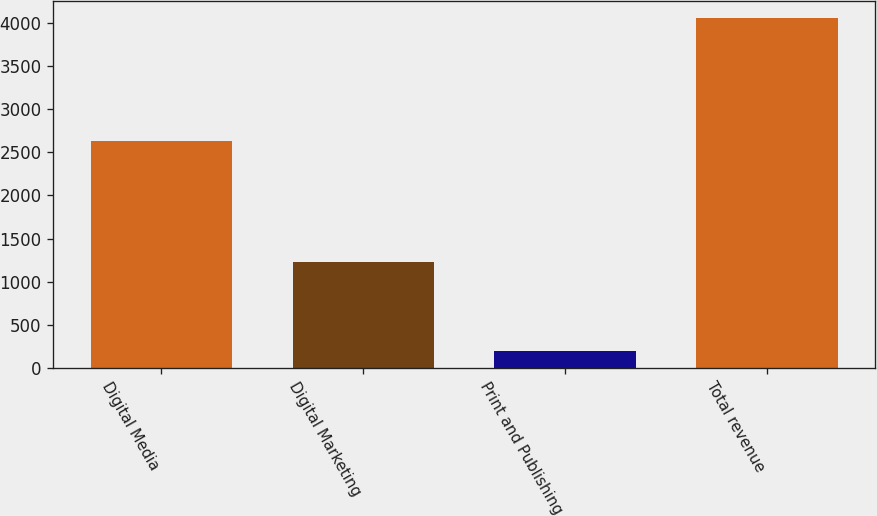<chart> <loc_0><loc_0><loc_500><loc_500><bar_chart><fcel>Digital Media<fcel>Digital Marketing<fcel>Print and Publishing<fcel>Total revenue<nl><fcel>2625.9<fcel>1228.8<fcel>200.5<fcel>4055.2<nl></chart> 